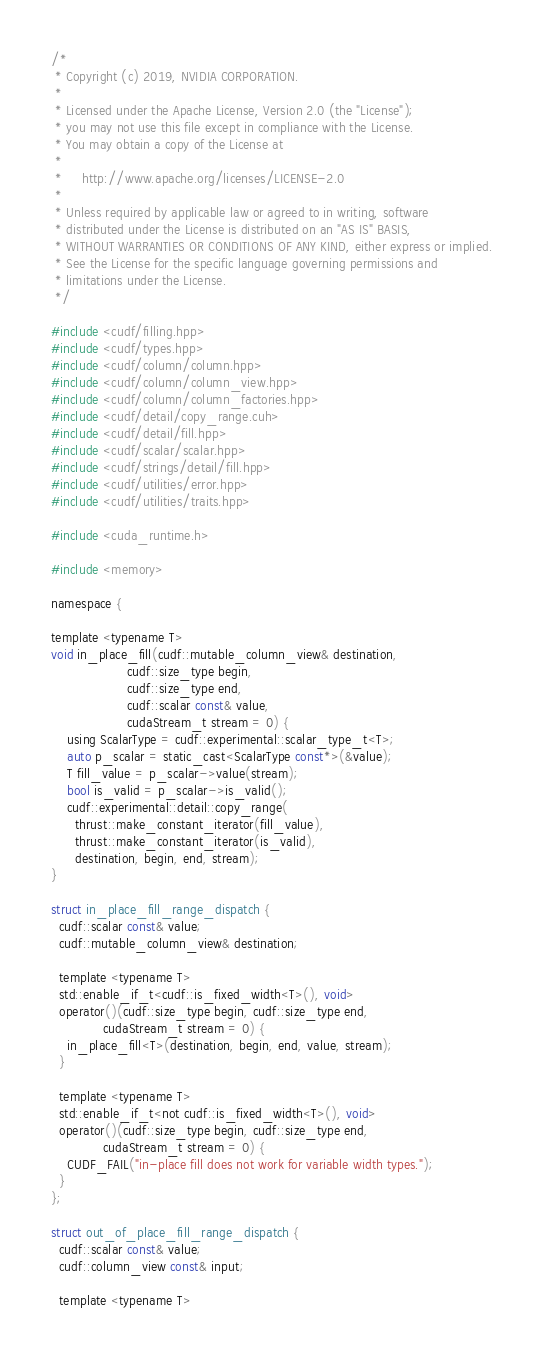<code> <loc_0><loc_0><loc_500><loc_500><_Cuda_>/*
 * Copyright (c) 2019, NVIDIA CORPORATION.
 *
 * Licensed under the Apache License, Version 2.0 (the "License");
 * you may not use this file except in compliance with the License.
 * You may obtain a copy of the License at
 *
 *     http://www.apache.org/licenses/LICENSE-2.0
 *
 * Unless required by applicable law or agreed to in writing, software
 * distributed under the License is distributed on an "AS IS" BASIS,
 * WITHOUT WARRANTIES OR CONDITIONS OF ANY KIND, either express or implied.
 * See the License for the specific language governing permissions and
 * limitations under the License.
 */

#include <cudf/filling.hpp>
#include <cudf/types.hpp>
#include <cudf/column/column.hpp>
#include <cudf/column/column_view.hpp>
#include <cudf/column/column_factories.hpp>
#include <cudf/detail/copy_range.cuh>
#include <cudf/detail/fill.hpp>
#include <cudf/scalar/scalar.hpp>
#include <cudf/strings/detail/fill.hpp>
#include <cudf/utilities/error.hpp>
#include <cudf/utilities/traits.hpp>

#include <cuda_runtime.h>

#include <memory>

namespace {

template <typename T>
void in_place_fill(cudf::mutable_column_view& destination,
                   cudf::size_type begin,
                   cudf::size_type end,
                   cudf::scalar const& value,
                   cudaStream_t stream = 0) {
    using ScalarType = cudf::experimental::scalar_type_t<T>;
    auto p_scalar = static_cast<ScalarType const*>(&value);
    T fill_value = p_scalar->value(stream);
    bool is_valid = p_scalar->is_valid();
    cudf::experimental::detail::copy_range(
      thrust::make_constant_iterator(fill_value),
      thrust::make_constant_iterator(is_valid),
      destination, begin, end, stream);
}

struct in_place_fill_range_dispatch {
  cudf::scalar const& value;
  cudf::mutable_column_view& destination;

  template <typename T>
  std::enable_if_t<cudf::is_fixed_width<T>(), void>
  operator()(cudf::size_type begin, cudf::size_type end,
             cudaStream_t stream = 0) {
    in_place_fill<T>(destination, begin, end, value, stream);
  }

  template <typename T>
  std::enable_if_t<not cudf::is_fixed_width<T>(), void>
  operator()(cudf::size_type begin, cudf::size_type end,
             cudaStream_t stream = 0) {
    CUDF_FAIL("in-place fill does not work for variable width types.");
  }
};

struct out_of_place_fill_range_dispatch {
  cudf::scalar const& value;
  cudf::column_view const& input;

  template <typename T></code> 